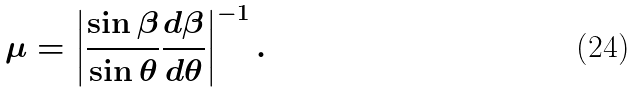Convert formula to latex. <formula><loc_0><loc_0><loc_500><loc_500>\mu = \left | \frac { \sin \beta } { \sin \theta } \frac { d \beta } { d \theta } \right | ^ { - 1 } .</formula> 